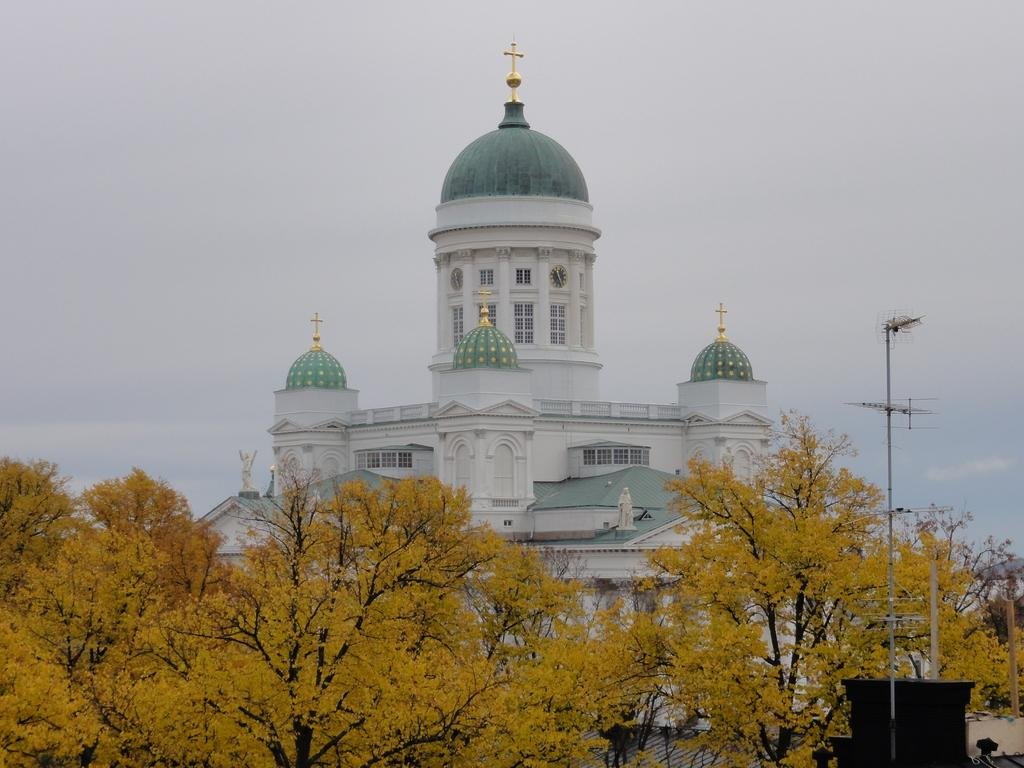What type of structure is visible in the image? There is a building in the image. What other natural elements can be seen in the image? There are trees in the image. What are the tall, thin objects in the image? There are poles in the image. What is located at the bottom of the image? There are objects at the bottom of the image. What part of the natural environment is visible in the image? The sky is visible in the image. What type of glue is being used by the servant in the image? There is no servant or glue present in the image. Is the person driving a car in the image? There is no person driving a car in the image. 